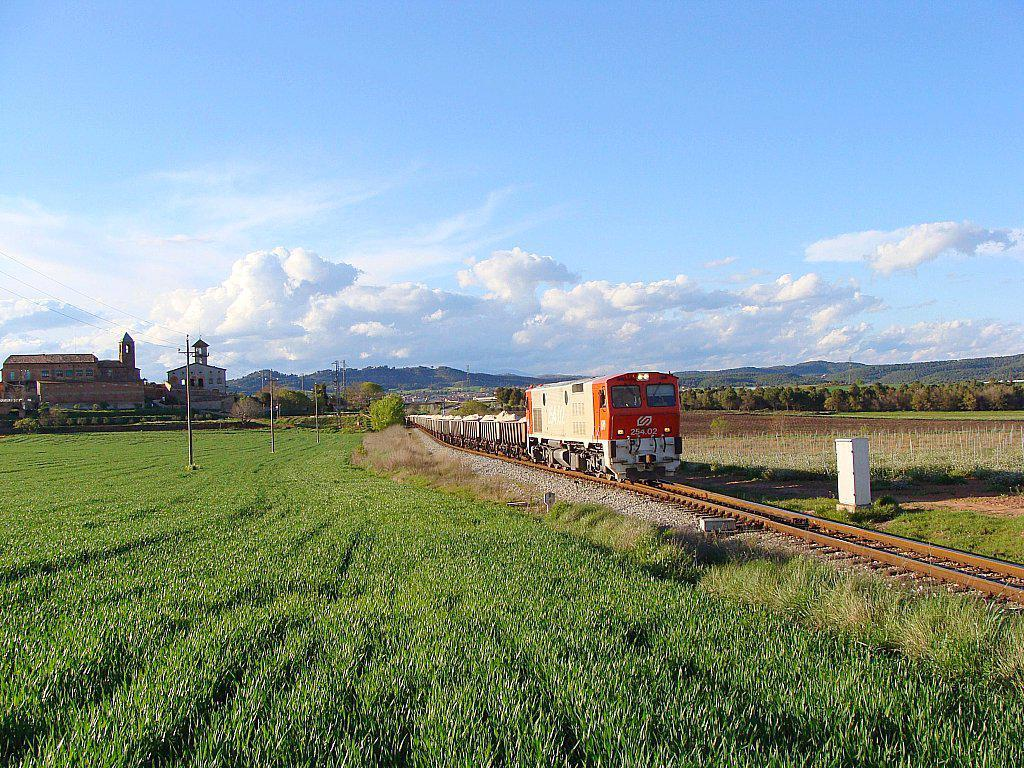What is the main subject of the image? The main subject of the image is a train. What is the train doing in the image? The train is moving on a railway track. What type of vegetation can be seen in the image? There is grass visible in the image. What infrastructure is present in the image? Current poles and wires are visible in the image. What type of natural features can be seen in the image? Trees, hills, and a cloudy sky are visible in the image. What type of buildings are present in the image? Houses are present in the image. What type of agreement is being signed by the train in the image? There is no agreement being signed in the image; it is a train moving on a railway track. Can you see any waves in the image? There are no waves present in the image; it features a train, railway track, and other elements mentioned in the conversation. 